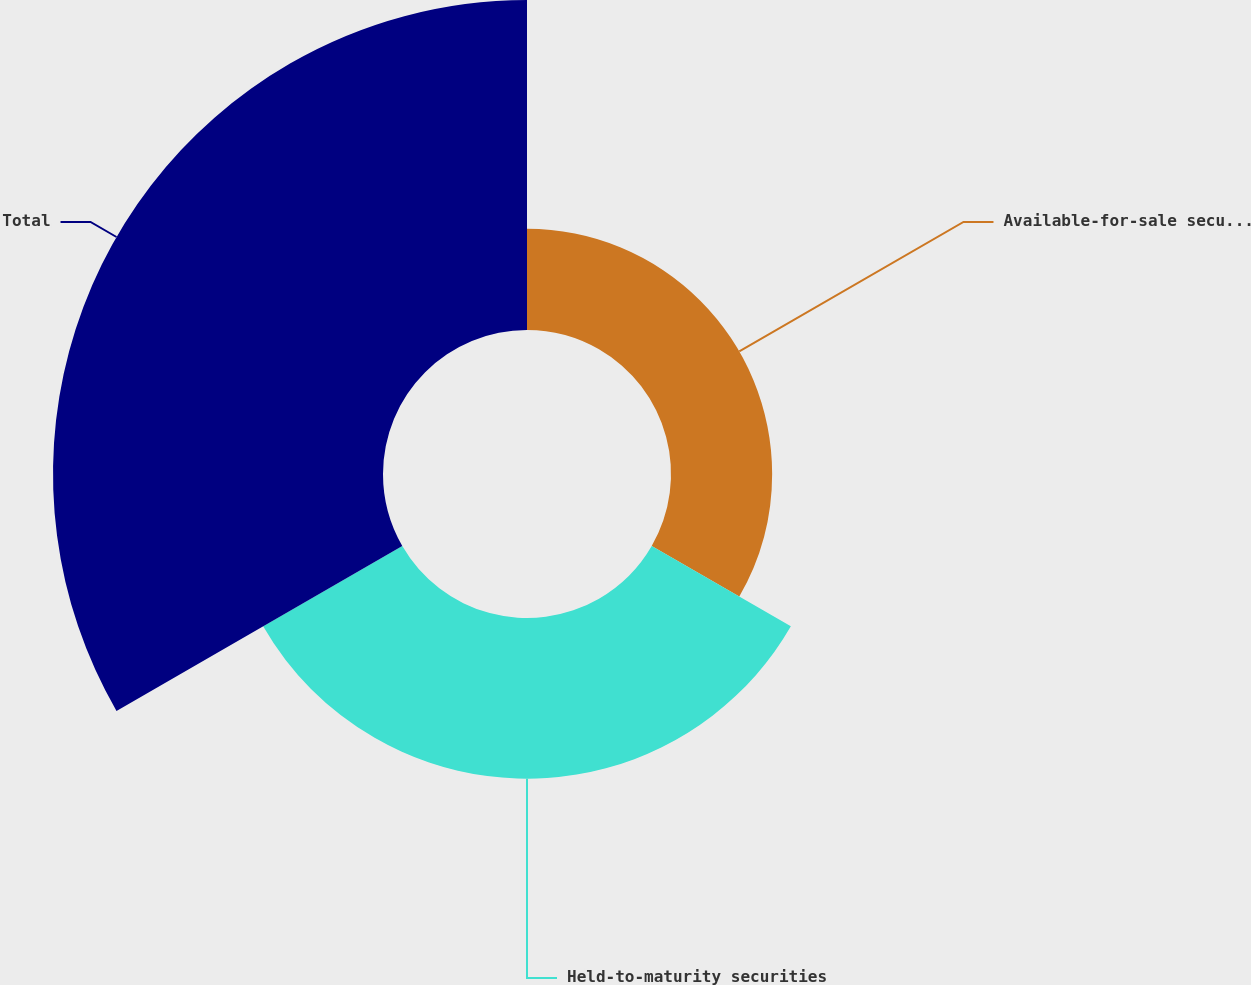Convert chart. <chart><loc_0><loc_0><loc_500><loc_500><pie_chart><fcel>Available-for-sale securities<fcel>Held-to-maturity securities<fcel>Total<nl><fcel>17.09%<fcel>27.15%<fcel>55.76%<nl></chart> 